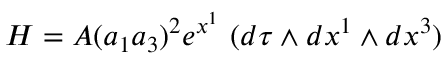<formula> <loc_0><loc_0><loc_500><loc_500>H = A ( a _ { 1 } a _ { 3 } ) ^ { 2 } e ^ { x ^ { 1 } } \, ( d \tau \wedge d x ^ { 1 } \wedge d x ^ { 3 } )</formula> 